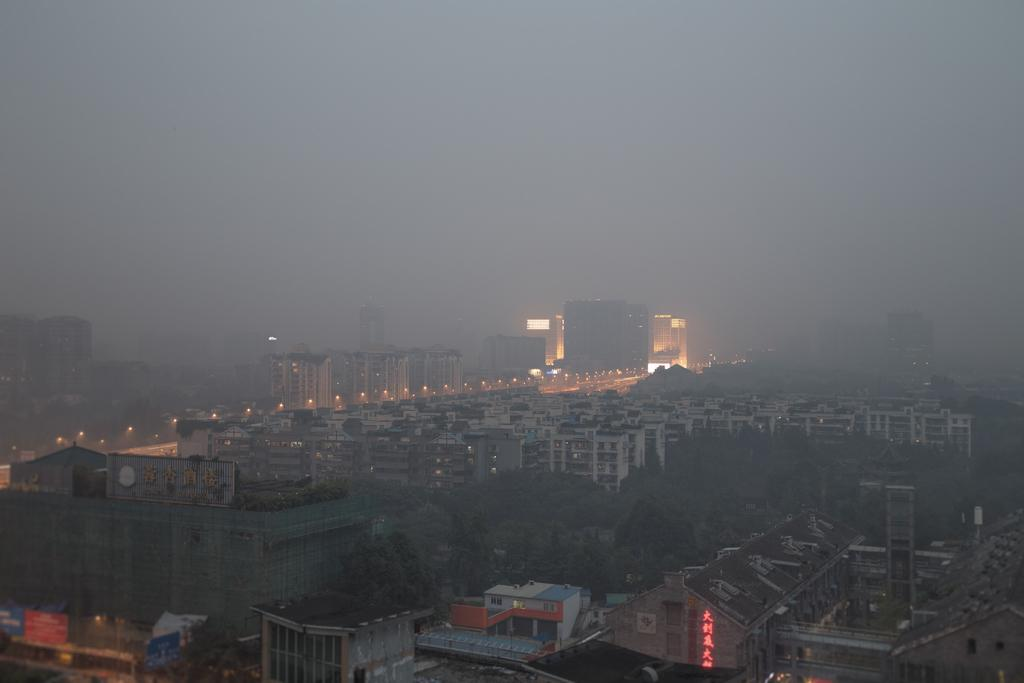What type of structures can be seen in the image? There are buildings and towers in the image. What are the lights attached to in the image? The lights are attached to poles in the image. What type of vegetation is present in the image? There are trees in the image. What other objects can be seen in the image besides buildings, towers, and trees? There are other objects in the image, but their specific details are not mentioned in the facts. What can be seen in the background of the image? Snow smoke is visible in the background of the image. Can you tell me how the zephyr affects the driving conditions in the image? There is no mention of a zephyr or driving conditions in the image. The image only shows buildings, towers, lights, trees, and snow smoke in the background. 